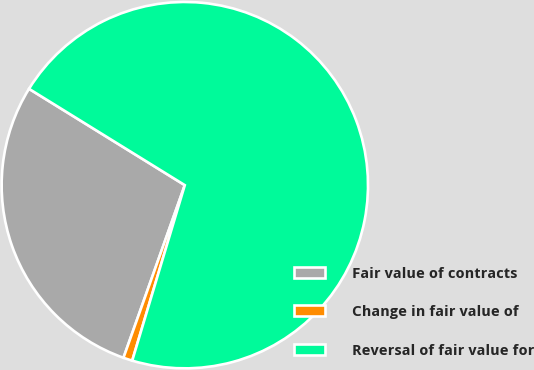<chart> <loc_0><loc_0><loc_500><loc_500><pie_chart><fcel>Fair value of contracts<fcel>Change in fair value of<fcel>Reversal of fair value for<nl><fcel>28.38%<fcel>0.8%<fcel>70.82%<nl></chart> 